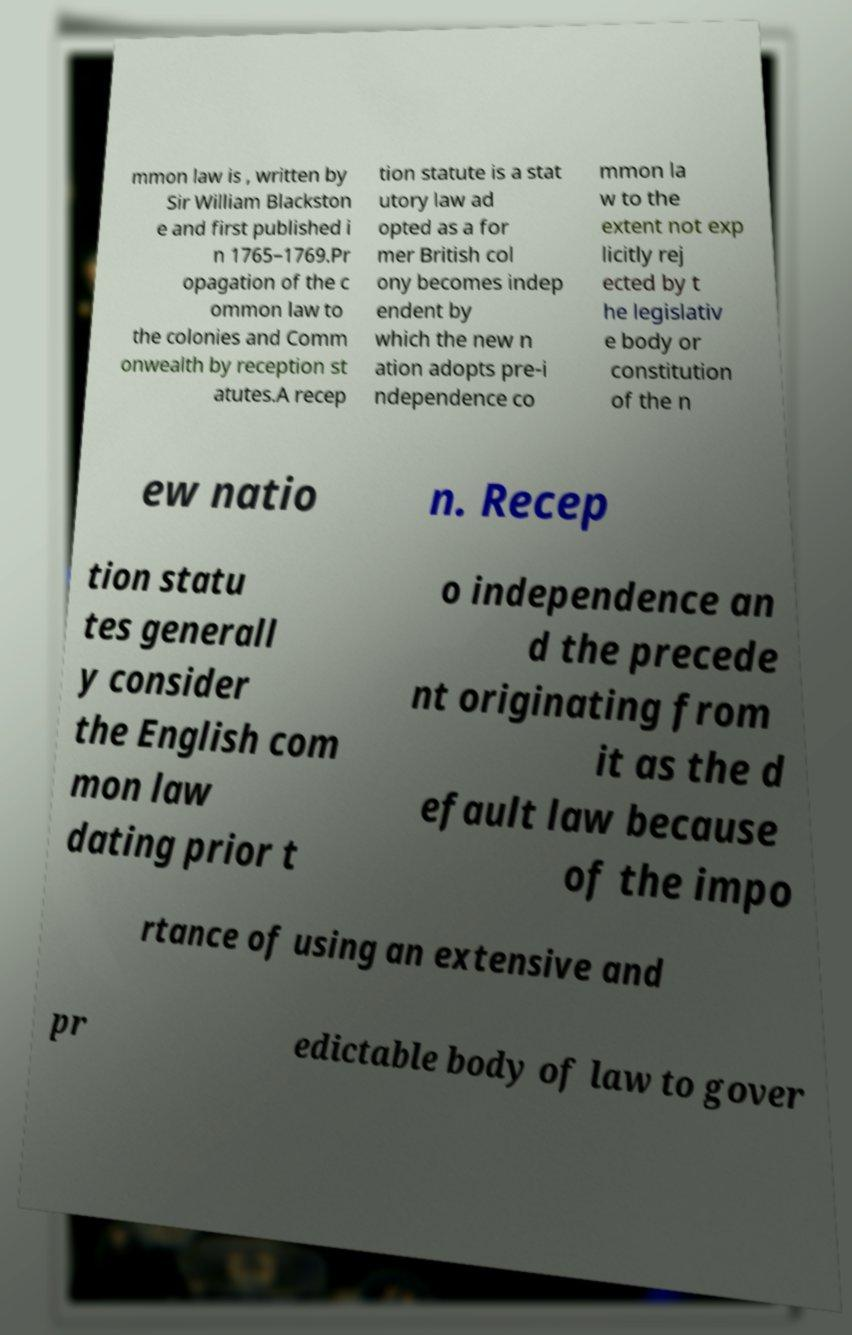What messages or text are displayed in this image? I need them in a readable, typed format. mmon law is , written by Sir William Blackston e and first published i n 1765–1769.Pr opagation of the c ommon law to the colonies and Comm onwealth by reception st atutes.A recep tion statute is a stat utory law ad opted as a for mer British col ony becomes indep endent by which the new n ation adopts pre-i ndependence co mmon la w to the extent not exp licitly rej ected by t he legislativ e body or constitution of the n ew natio n. Recep tion statu tes generall y consider the English com mon law dating prior t o independence an d the precede nt originating from it as the d efault law because of the impo rtance of using an extensive and pr edictable body of law to gover 